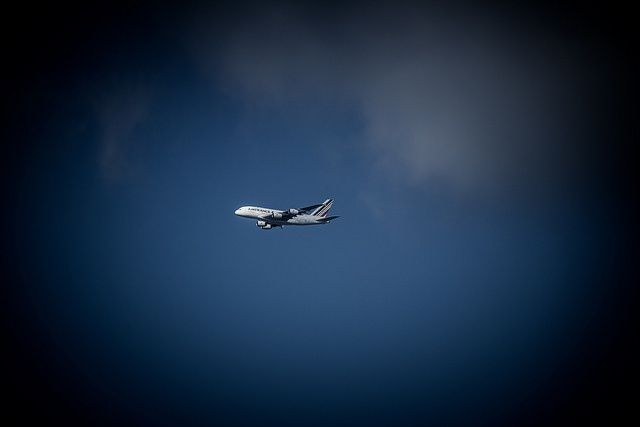Describe the objects in this image and their specific colors. I can see a airplane in black, darkgray, lightgray, and gray tones in this image. 